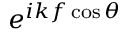Convert formula to latex. <formula><loc_0><loc_0><loc_500><loc_500>e ^ { i k f \cos \theta }</formula> 